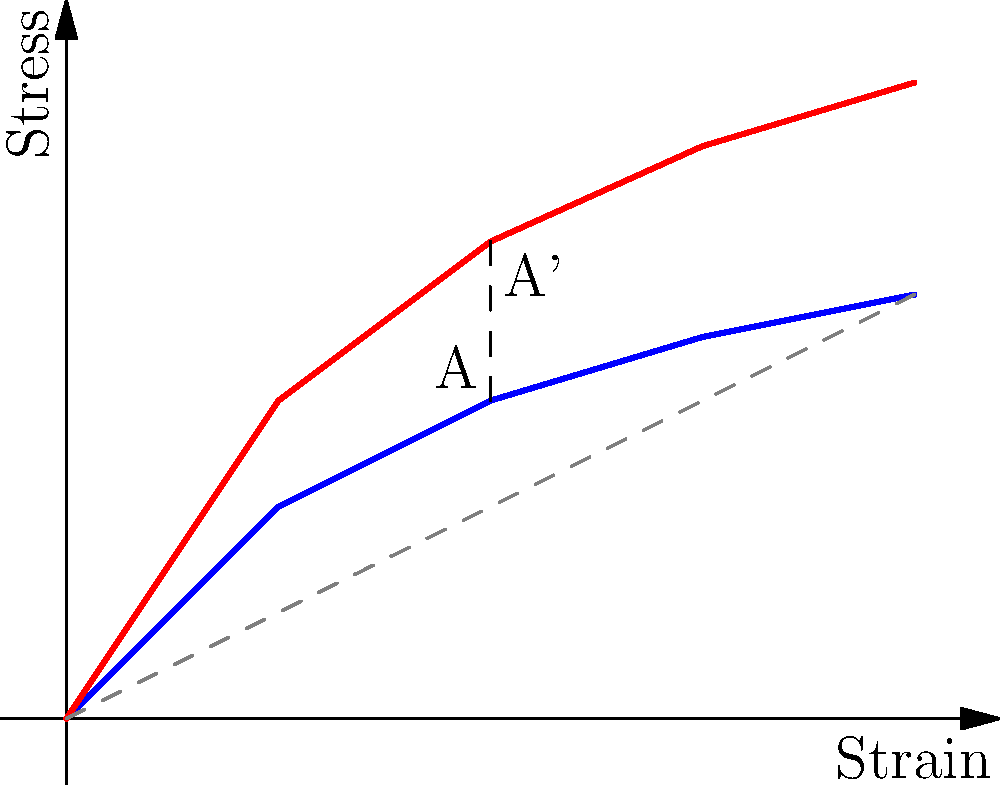In the stress-strain diagram for a glass material, a shear transformation has been applied. If point A on the original curve (blue) is transformed to point A' on the sheared curve (red), and the shear factor is $k$, what is the value of $k$ given that the vertical displacement between A and A' is 0.75 units? To solve this problem, we need to understand the concept of shear transformation and how it affects the stress-strain diagram. Let's approach this step-by-step:

1) In a shear transformation, each point $(x, y)$ is transformed to $(x, y + kx)$, where $k$ is the shear factor.

2) The original point A has coordinates $(2, 1.5)$.

3) After the shear transformation, point A' has y-coordinate $2.25$, as we can see from the diagram.

4) The vertical displacement between A and A' is given as 0.75 units.

5) Using the shear transformation formula:
   $y' = y + kx$
   $2.25 = 1.5 + k(2)$

6) Solving for $k$:
   $0.75 = k(2)$
   $k = 0.75 / 2 = 0.375$

Therefore, the shear factor $k$ is 0.375.
Answer: $k = 0.375$ 